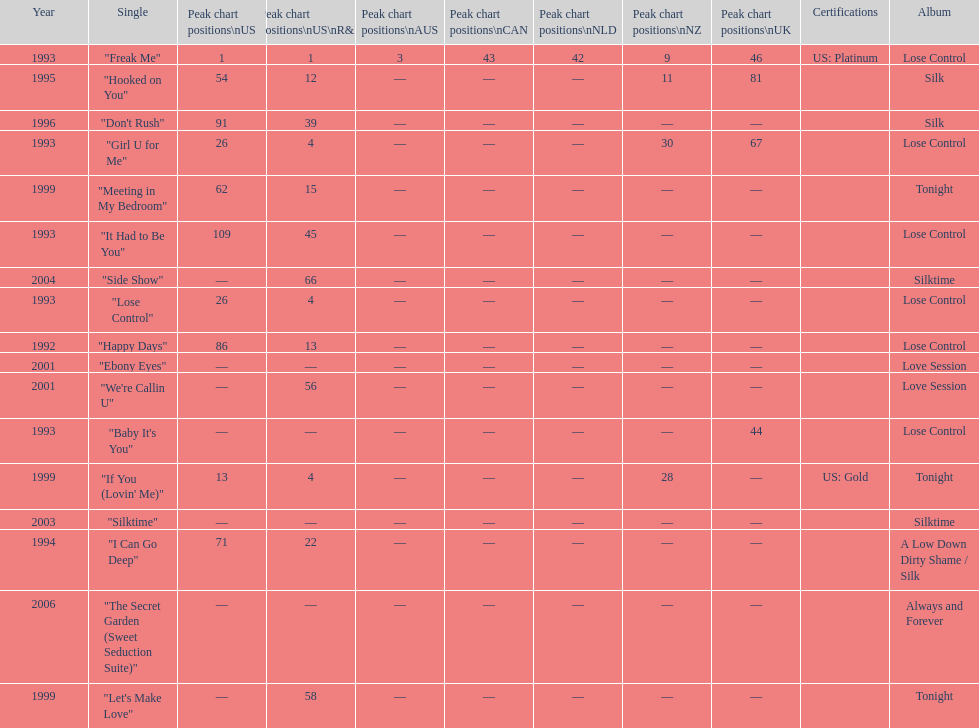Which single is the most in terms of how many times it charted? "Freak Me". 